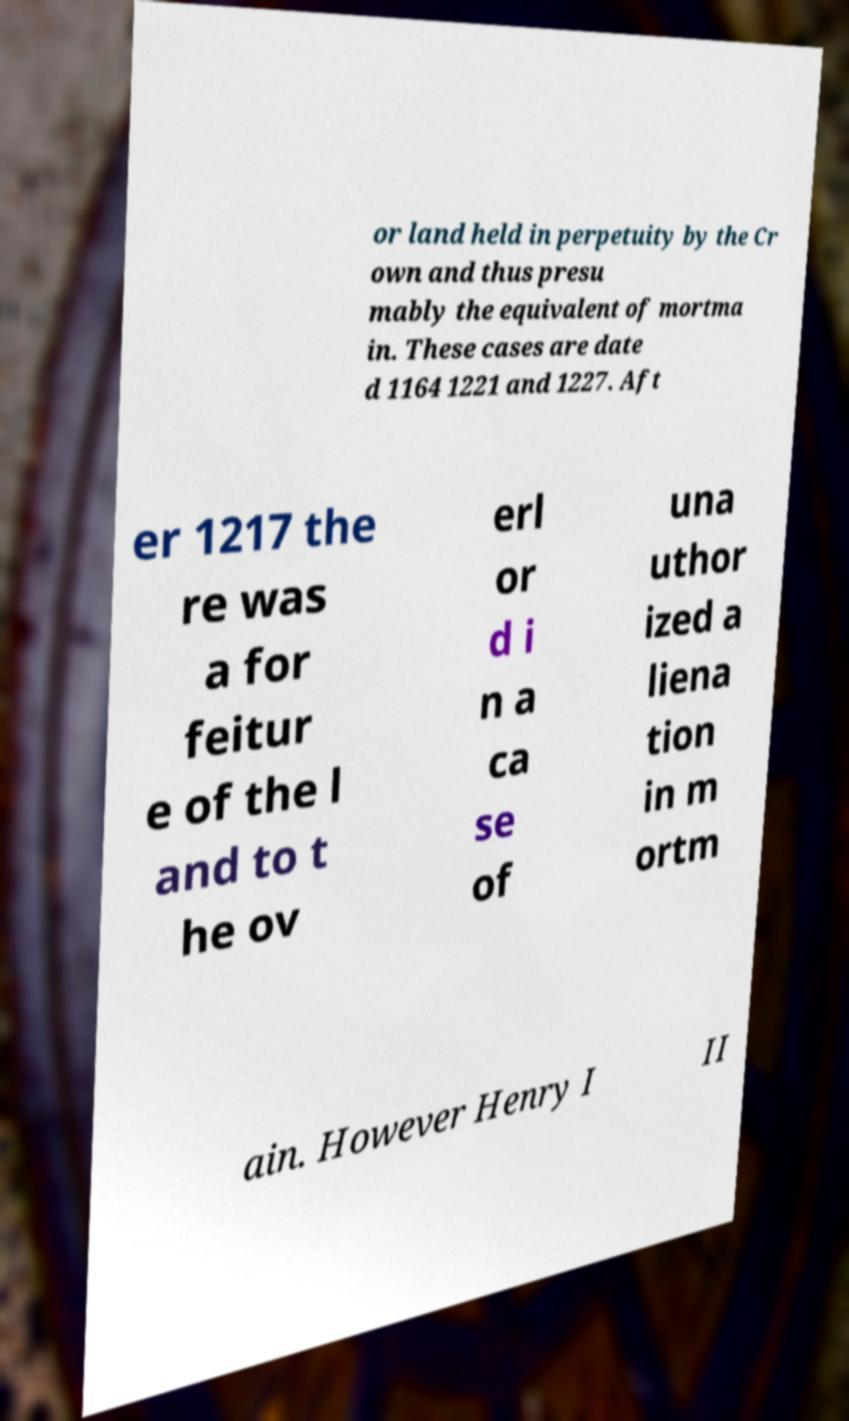Please read and relay the text visible in this image. What does it say? or land held in perpetuity by the Cr own and thus presu mably the equivalent of mortma in. These cases are date d 1164 1221 and 1227. Aft er 1217 the re was a for feitur e of the l and to t he ov erl or d i n a ca se of una uthor ized a liena tion in m ortm ain. However Henry I II 